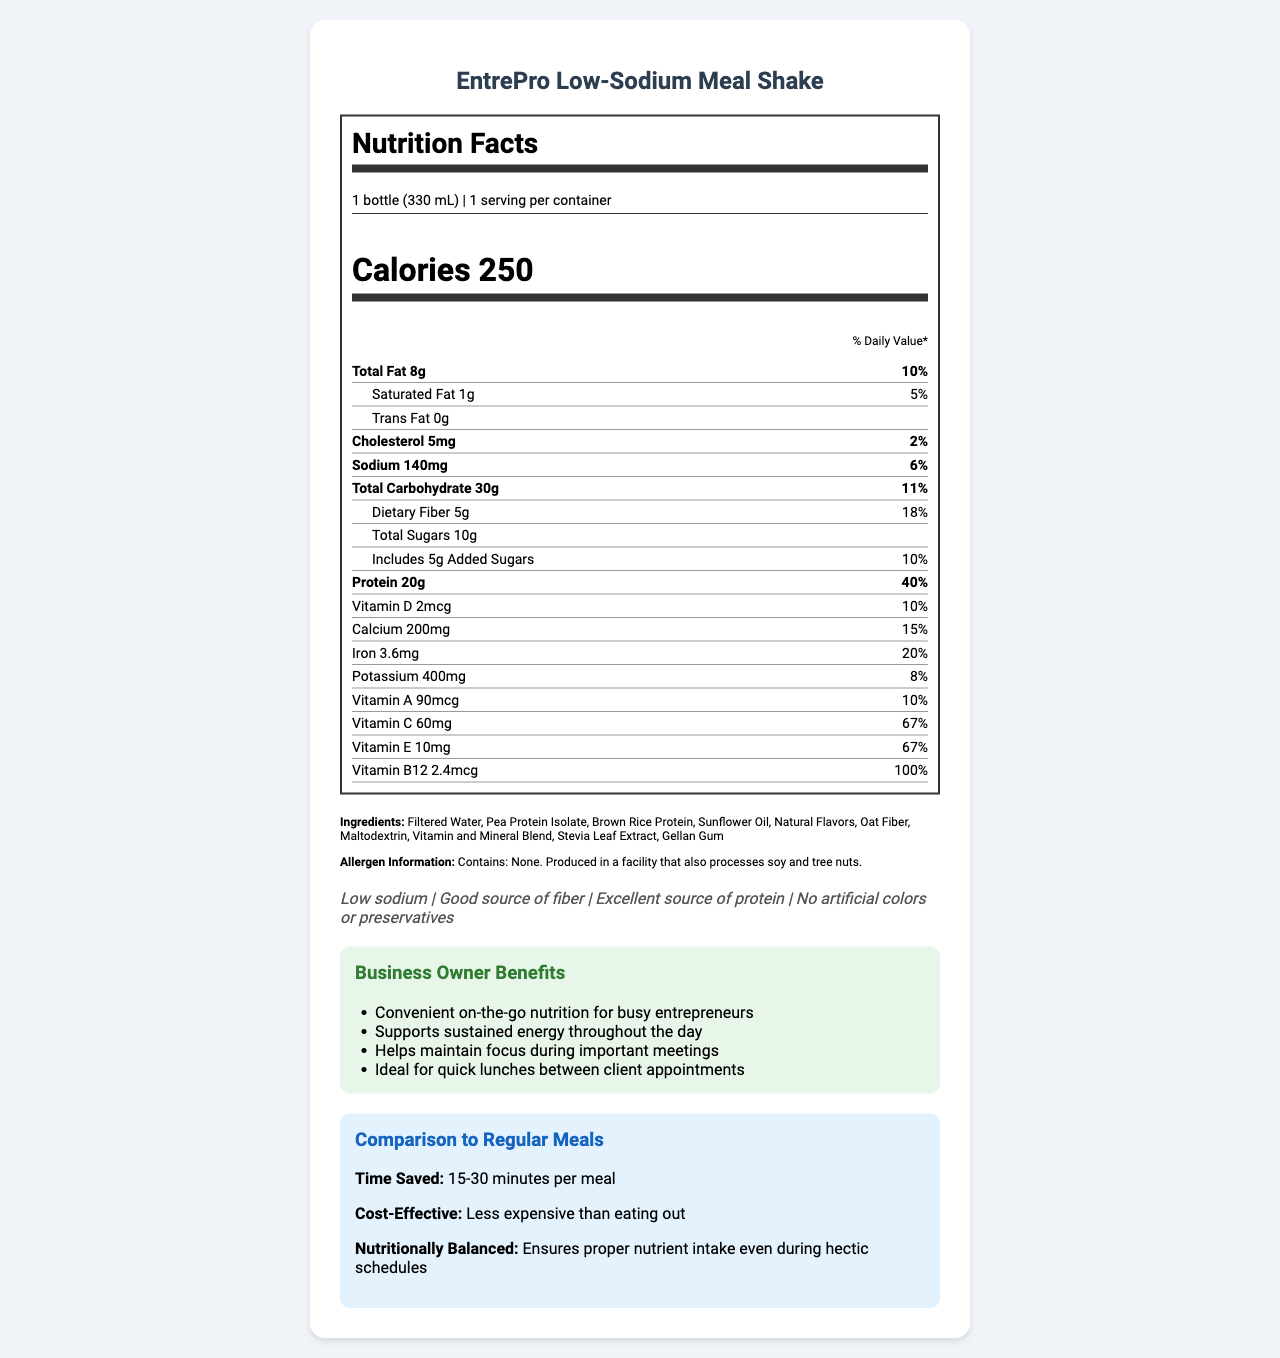what is the serving size for the EntrePro Low-Sodium Meal Shake? The serving size is stated under the "Nutrition Facts" section.
Answer: 1 bottle (330 mL) How many calories are there in one serving of this meal replacement shake? The calorie count is listed in the "Nutrition Facts" section under an emphasized "Calories" header.
Answer: 250 What percentage of the daily value of protein does this product provide? The protein content is listed as 20g, which is 40% of the daily value, in the "Nutrition Facts" section.
Answer: 40% What is the sodium content per serving of the EntrePro Low-Sodium Meal Shake? The sodium amount per serving is listed under the "Nutrition Facts" section.
Answer: 140mg Does this product contain any trans fats? Under the "Nutrition Facts" section, it is specifically mentioned that trans fat is 0g.
Answer: No What are the main ingredients in the EntrePro Low-Sodium Meal Shake? A. Filtered Water, Pea Protein Isolate, Natural Flavors B. Filtered Water, Pea Protein Isolate, Sunflower Oil C. Filtered Water, Brown Rice Protein, Oat Fiber D. Filtered Water, Vitamin and Mineral Blend, Stevia Leaf Extract The main ingredients are "Filtered Water, Pea Protein Isolate, Sunflower Oil" among others.
Answer: B Which of these vitamins has the highest percentage of daily value in the entrePro Low-Sodium Meal Shake? A. Vitamin D B. Vitamin B12 C. Vitamin C D. Vitamin E Vitamin B12 has 100% daily value compared to other vitamins mentioned.
Answer: B Is the product an excellent source of protein? It is stated in the claim statements under "Excellent source of protein."
Answer: Yes Summarize the main benefits of the EntrePro Low-Sodium Meal Shake for busy business owners. The document's "Business Owner Benefits" section outlines these primary benefits targeted specifically for business owners.
Answer: The EntrePro Low-Sodium Meal Shake offers convenient on-the-go nutrition, supports sustained energy throughout the day, helps maintain focus during important meetings, and is ideal for quick lunches between client appointments. What allergens are present in the EntrePro Low-Sodium Meal Shake? The "Allergen Information" clearly states that the product contains no allergens, but is produced in a facility that processes soy and tree nuts.
Answer: None What specific claim is made about the sodium content in the EntrePro Low-Sodium Meal Shake? In the claim statements, it specifically mentions "Low sodium."
Answer: Low sodium How much time does this product save compared to regular meals? This information is found in the "Comparison to Regular Meals" section.
Answer: 15-30 minutes per meal Which vitamin has the lowest milligram quantity? Vitamin D is listed as 2mcg in the nutrient section, which is the lowest among the other vitamins listed.
Answer: Vitamin D What is the cost benefit of consuming this meal replacement shake compared to eating out? This information is provided in the "Comparison to Regular Meals" section.
Answer: Less expensive than eating out Could someone with a tree nut allergy safely consume this product? The product itself contains no allergens, but it is produced in a facility that processes tree nuts. The safety for someone with a severe allergy cannot be fully determined without more information.
Answer: Cannot be determined 